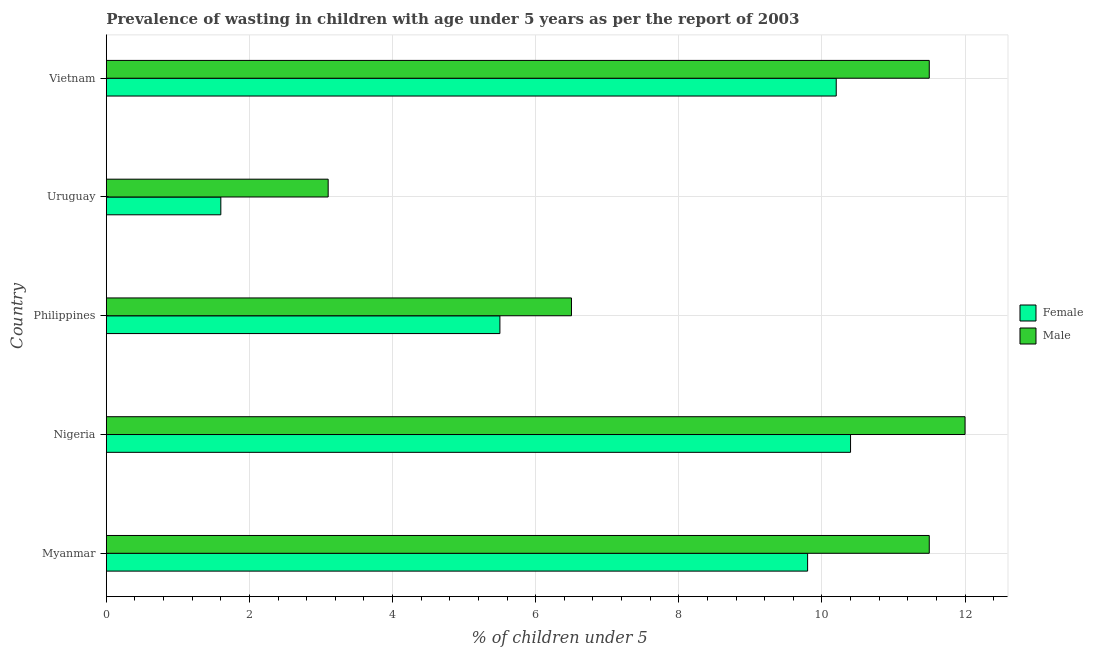How many different coloured bars are there?
Offer a terse response. 2. How many groups of bars are there?
Offer a very short reply. 5. Are the number of bars per tick equal to the number of legend labels?
Offer a very short reply. Yes. How many bars are there on the 2nd tick from the bottom?
Give a very brief answer. 2. What is the label of the 4th group of bars from the top?
Make the answer very short. Nigeria. Across all countries, what is the maximum percentage of undernourished female children?
Your answer should be very brief. 10.4. Across all countries, what is the minimum percentage of undernourished female children?
Ensure brevity in your answer.  1.6. In which country was the percentage of undernourished female children maximum?
Provide a succinct answer. Nigeria. In which country was the percentage of undernourished male children minimum?
Give a very brief answer. Uruguay. What is the total percentage of undernourished male children in the graph?
Your answer should be very brief. 44.6. What is the difference between the percentage of undernourished male children in Myanmar and that in Uruguay?
Make the answer very short. 8.4. What is the difference between the percentage of undernourished male children in Vietnam and the percentage of undernourished female children in Myanmar?
Offer a very short reply. 1.7. What is the difference between the percentage of undernourished male children and percentage of undernourished female children in Nigeria?
Offer a very short reply. 1.6. In how many countries, is the percentage of undernourished female children greater than 4.8 %?
Offer a very short reply. 4. Is the difference between the percentage of undernourished female children in Myanmar and Uruguay greater than the difference between the percentage of undernourished male children in Myanmar and Uruguay?
Provide a succinct answer. No. What is the difference between the highest and the second highest percentage of undernourished male children?
Offer a terse response. 0.5. What is the difference between the highest and the lowest percentage of undernourished male children?
Provide a succinct answer. 8.9. What does the 2nd bar from the top in Vietnam represents?
Make the answer very short. Female. What does the 1st bar from the bottom in Philippines represents?
Your response must be concise. Female. How many bars are there?
Keep it short and to the point. 10. Are the values on the major ticks of X-axis written in scientific E-notation?
Your answer should be compact. No. Does the graph contain any zero values?
Provide a succinct answer. No. Where does the legend appear in the graph?
Keep it short and to the point. Center right. How many legend labels are there?
Your answer should be compact. 2. How are the legend labels stacked?
Provide a succinct answer. Vertical. What is the title of the graph?
Your answer should be compact. Prevalence of wasting in children with age under 5 years as per the report of 2003. Does "% of gross capital formation" appear as one of the legend labels in the graph?
Provide a short and direct response. No. What is the label or title of the X-axis?
Make the answer very short.  % of children under 5. What is the  % of children under 5 of Female in Myanmar?
Keep it short and to the point. 9.8. What is the  % of children under 5 in Female in Nigeria?
Your answer should be compact. 10.4. What is the  % of children under 5 of Male in Philippines?
Keep it short and to the point. 6.5. What is the  % of children under 5 in Female in Uruguay?
Offer a very short reply. 1.6. What is the  % of children under 5 in Male in Uruguay?
Provide a succinct answer. 3.1. What is the  % of children under 5 in Female in Vietnam?
Ensure brevity in your answer.  10.2. Across all countries, what is the maximum  % of children under 5 in Female?
Give a very brief answer. 10.4. Across all countries, what is the minimum  % of children under 5 in Female?
Your response must be concise. 1.6. Across all countries, what is the minimum  % of children under 5 in Male?
Make the answer very short. 3.1. What is the total  % of children under 5 of Female in the graph?
Provide a succinct answer. 37.5. What is the total  % of children under 5 of Male in the graph?
Keep it short and to the point. 44.6. What is the difference between the  % of children under 5 in Female in Myanmar and that in Nigeria?
Your answer should be compact. -0.6. What is the difference between the  % of children under 5 of Male in Myanmar and that in Nigeria?
Ensure brevity in your answer.  -0.5. What is the difference between the  % of children under 5 of Male in Myanmar and that in Uruguay?
Offer a very short reply. 8.4. What is the difference between the  % of children under 5 of Female in Myanmar and that in Vietnam?
Give a very brief answer. -0.4. What is the difference between the  % of children under 5 of Male in Myanmar and that in Vietnam?
Provide a short and direct response. 0. What is the difference between the  % of children under 5 in Female in Nigeria and that in Philippines?
Offer a very short reply. 4.9. What is the difference between the  % of children under 5 of Male in Nigeria and that in Philippines?
Give a very brief answer. 5.5. What is the difference between the  % of children under 5 of Female in Nigeria and that in Uruguay?
Provide a short and direct response. 8.8. What is the difference between the  % of children under 5 in Female in Nigeria and that in Vietnam?
Offer a very short reply. 0.2. What is the difference between the  % of children under 5 in Male in Nigeria and that in Vietnam?
Your response must be concise. 0.5. What is the difference between the  % of children under 5 of Male in Philippines and that in Uruguay?
Provide a succinct answer. 3.4. What is the difference between the  % of children under 5 in Female in Philippines and that in Vietnam?
Give a very brief answer. -4.7. What is the difference between the  % of children under 5 in Male in Uruguay and that in Vietnam?
Keep it short and to the point. -8.4. What is the difference between the  % of children under 5 of Female in Myanmar and the  % of children under 5 of Male in Nigeria?
Make the answer very short. -2.2. What is the difference between the  % of children under 5 of Female in Myanmar and the  % of children under 5 of Male in Uruguay?
Ensure brevity in your answer.  6.7. What is the difference between the  % of children under 5 in Female in Myanmar and the  % of children under 5 in Male in Vietnam?
Offer a very short reply. -1.7. What is the difference between the  % of children under 5 in Female in Nigeria and the  % of children under 5 in Male in Vietnam?
Keep it short and to the point. -1.1. What is the difference between the  % of children under 5 in Female in Philippines and the  % of children under 5 in Male in Uruguay?
Offer a very short reply. 2.4. What is the average  % of children under 5 of Female per country?
Your answer should be very brief. 7.5. What is the average  % of children under 5 of Male per country?
Your response must be concise. 8.92. What is the difference between the  % of children under 5 of Female and  % of children under 5 of Male in Uruguay?
Make the answer very short. -1.5. What is the difference between the  % of children under 5 in Female and  % of children under 5 in Male in Vietnam?
Your answer should be very brief. -1.3. What is the ratio of the  % of children under 5 of Female in Myanmar to that in Nigeria?
Your answer should be compact. 0.94. What is the ratio of the  % of children under 5 in Female in Myanmar to that in Philippines?
Give a very brief answer. 1.78. What is the ratio of the  % of children under 5 of Male in Myanmar to that in Philippines?
Provide a succinct answer. 1.77. What is the ratio of the  % of children under 5 in Female in Myanmar to that in Uruguay?
Provide a succinct answer. 6.12. What is the ratio of the  % of children under 5 in Male in Myanmar to that in Uruguay?
Your answer should be very brief. 3.71. What is the ratio of the  % of children under 5 in Female in Myanmar to that in Vietnam?
Give a very brief answer. 0.96. What is the ratio of the  % of children under 5 in Male in Myanmar to that in Vietnam?
Keep it short and to the point. 1. What is the ratio of the  % of children under 5 in Female in Nigeria to that in Philippines?
Offer a very short reply. 1.89. What is the ratio of the  % of children under 5 of Male in Nigeria to that in Philippines?
Your answer should be compact. 1.85. What is the ratio of the  % of children under 5 of Male in Nigeria to that in Uruguay?
Make the answer very short. 3.87. What is the ratio of the  % of children under 5 in Female in Nigeria to that in Vietnam?
Your response must be concise. 1.02. What is the ratio of the  % of children under 5 of Male in Nigeria to that in Vietnam?
Make the answer very short. 1.04. What is the ratio of the  % of children under 5 of Female in Philippines to that in Uruguay?
Provide a short and direct response. 3.44. What is the ratio of the  % of children under 5 in Male in Philippines to that in Uruguay?
Your answer should be compact. 2.1. What is the ratio of the  % of children under 5 in Female in Philippines to that in Vietnam?
Offer a terse response. 0.54. What is the ratio of the  % of children under 5 of Male in Philippines to that in Vietnam?
Make the answer very short. 0.57. What is the ratio of the  % of children under 5 in Female in Uruguay to that in Vietnam?
Your answer should be very brief. 0.16. What is the ratio of the  % of children under 5 of Male in Uruguay to that in Vietnam?
Make the answer very short. 0.27. What is the difference between the highest and the second highest  % of children under 5 of Female?
Offer a very short reply. 0.2. What is the difference between the highest and the second highest  % of children under 5 in Male?
Your answer should be compact. 0.5. What is the difference between the highest and the lowest  % of children under 5 of Female?
Your answer should be compact. 8.8. What is the difference between the highest and the lowest  % of children under 5 of Male?
Keep it short and to the point. 8.9. 